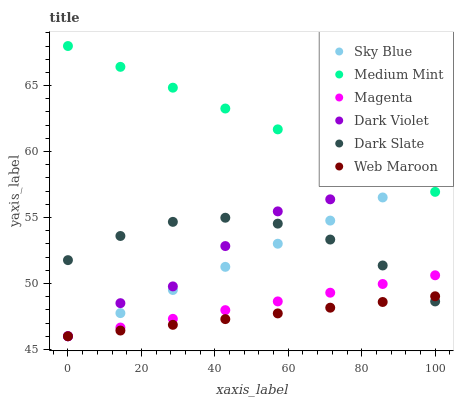Does Web Maroon have the minimum area under the curve?
Answer yes or no. Yes. Does Medium Mint have the maximum area under the curve?
Answer yes or no. Yes. Does Dark Violet have the minimum area under the curve?
Answer yes or no. No. Does Dark Violet have the maximum area under the curve?
Answer yes or no. No. Is Magenta the smoothest?
Answer yes or no. Yes. Is Dark Violet the roughest?
Answer yes or no. Yes. Is Web Maroon the smoothest?
Answer yes or no. No. Is Web Maroon the roughest?
Answer yes or no. No. Does Web Maroon have the lowest value?
Answer yes or no. Yes. Does Dark Slate have the lowest value?
Answer yes or no. No. Does Medium Mint have the highest value?
Answer yes or no. Yes. Does Dark Violet have the highest value?
Answer yes or no. No. Is Web Maroon less than Medium Mint?
Answer yes or no. Yes. Is Medium Mint greater than Web Maroon?
Answer yes or no. Yes. Does Sky Blue intersect Dark Violet?
Answer yes or no. Yes. Is Sky Blue less than Dark Violet?
Answer yes or no. No. Is Sky Blue greater than Dark Violet?
Answer yes or no. No. Does Web Maroon intersect Medium Mint?
Answer yes or no. No. 